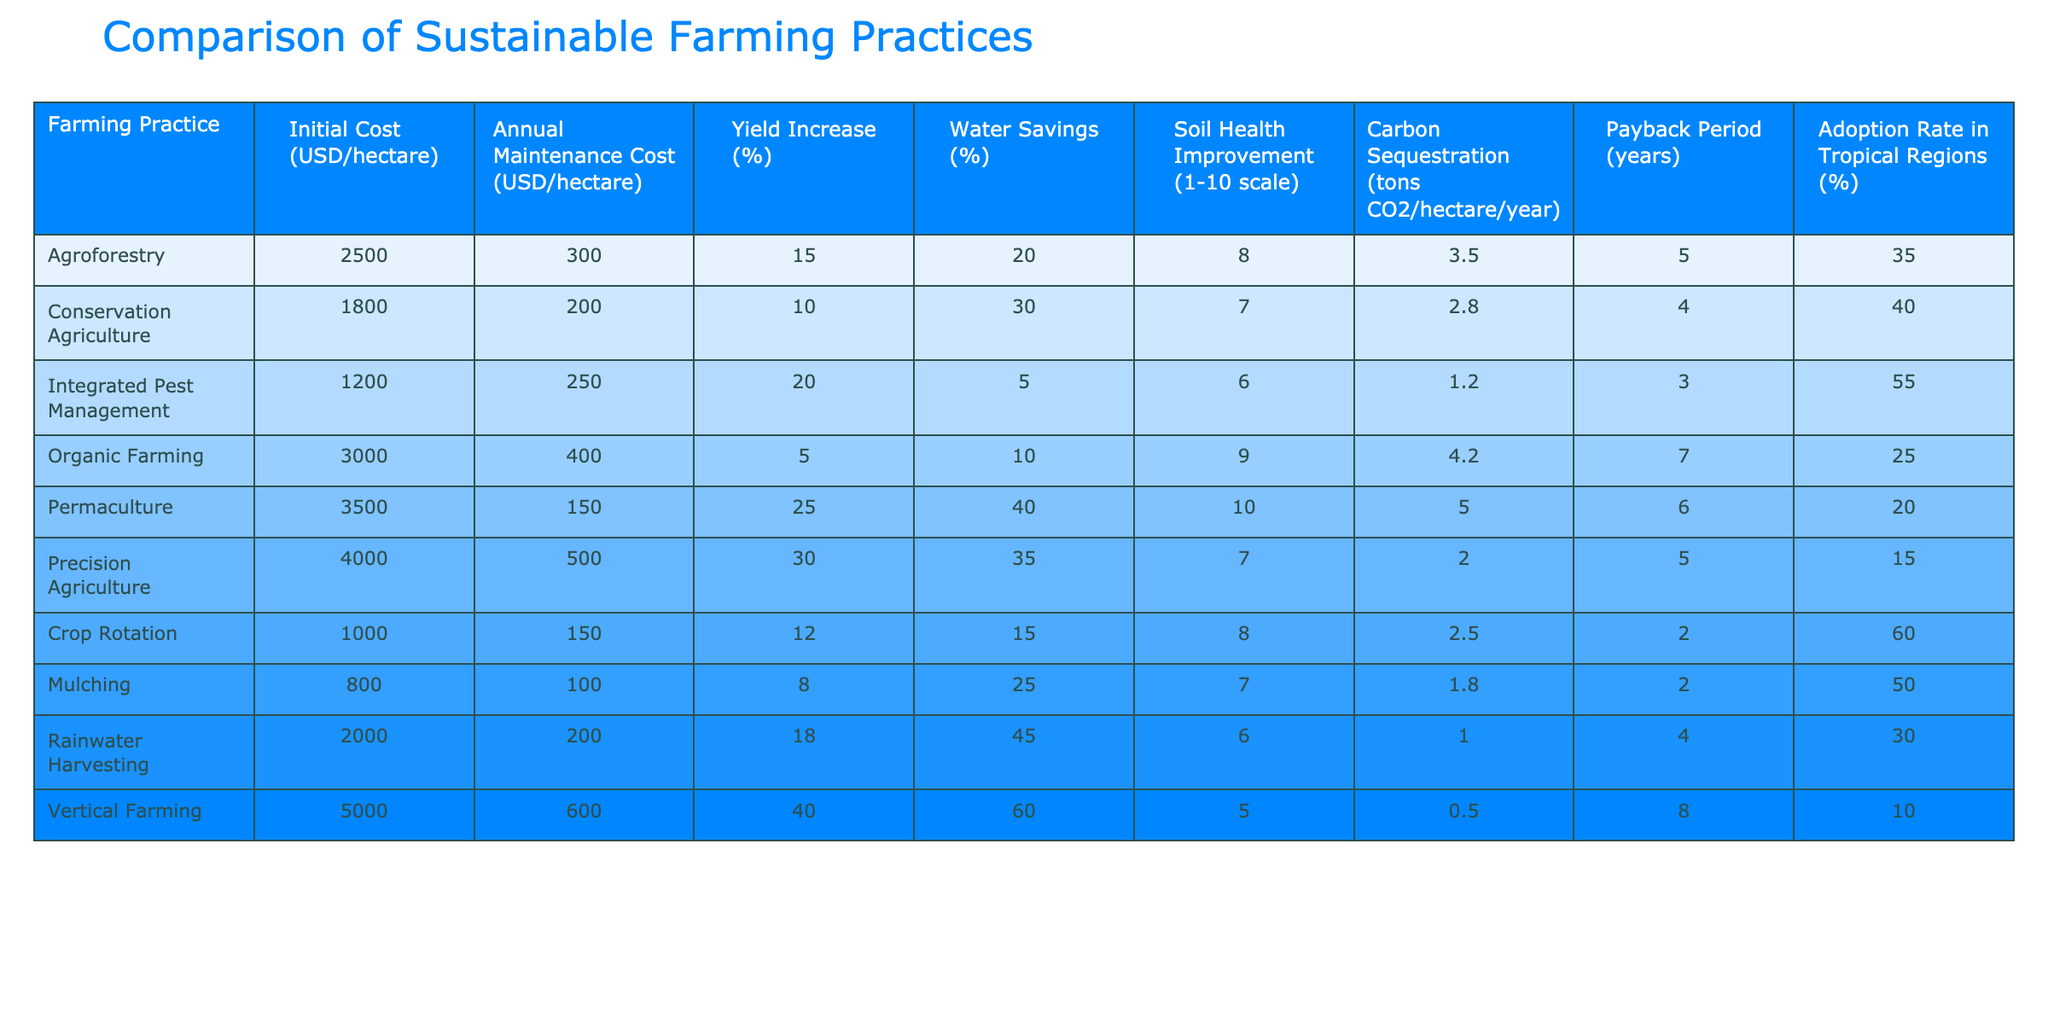What is the initial cost of Permaculture per hectare? The table indicates that the initial cost for Permaculture is listed directly under "Initial Cost (USD/hectare)" as 3500.
Answer: 3500 Which farming practice has the highest yield increase percentage? By reviewing the "Yield Increase (%)" column, Permaculture shows the highest value at 25%.
Answer: 25 Is the annual maintenance cost for Integrated Pest Management higher than that of Crop Rotation? The annual maintenance cost for Integrated Pest Management is 250, while for Crop Rotation it is 150. Since 250 is greater than 150, the statement is true.
Answer: Yes What is the average payback period for Agroforestry and Rainwater Harvesting? The payback period for Agroforestry is 5 years and for Rainwater Harvesting is 4 years. Summing these gives 9 years, divided by 2 gives an average of 4.5 years.
Answer: 4.5 Which farming practice has the highest carbon sequestration potential? The table shows that Permaculture has the highest carbon sequestration at 5.0 tons CO2/hectare/year, making it the most effective choice in that category.
Answer: 5.0 Are there any practices with an adoption rate of over 50%? Looking under the "Adoption Rate in Tropical Regions (%)" column, Integrated Pest Management at 55% is greater than 50%, so the answer is true.
Answer: Yes Calculate the total initial cost of the two most expensive farming practices. The initial costs of the two most expensive practices, Vertical Farming (5000) and Permaculture (3500), are added to yield a total of 8500.
Answer: 8500 Which two farming practices provide the highest water savings percentage? Reviewing the "Water Savings (%)" column, Vertical Farming (60%) and Precision Agriculture (35%) provide the highest percentages.
Answer: 60% and 35% Do Conservation Agriculture and Crop Rotation improve soil health equally? Conservation Agriculture has a soil health improvement score of 7, while Crop Rotation has a score of 8. Since they differ, the statement is false.
Answer: No 